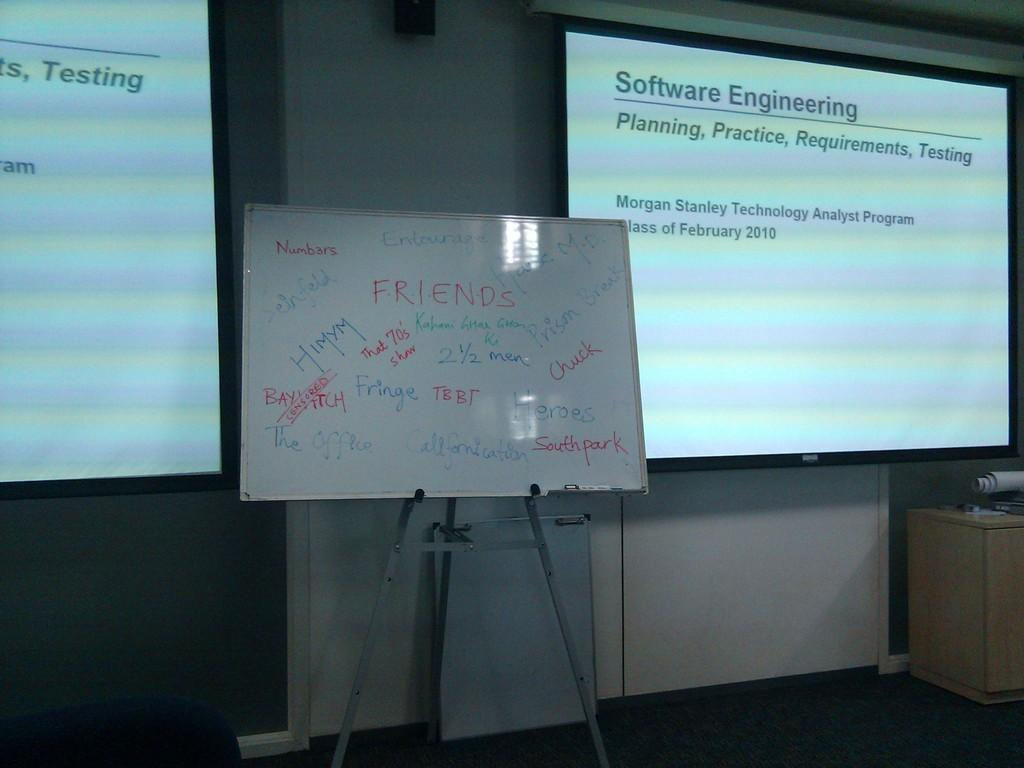<image>
Share a concise interpretation of the image provided. A classroom with Software Engineering slides at the front. 